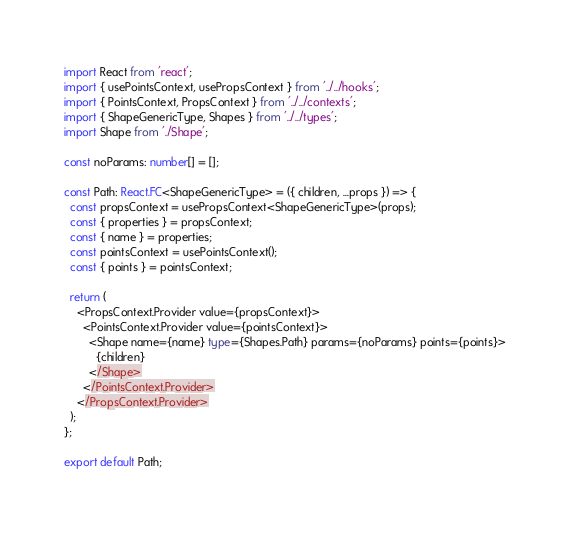<code> <loc_0><loc_0><loc_500><loc_500><_TypeScript_>import React from 'react';
import { usePointsContext, usePropsContext } from '../../hooks';
import { PointsContext, PropsContext } from '../../contexts';
import { ShapeGenericType, Shapes } from '../../types';
import Shape from './Shape';

const noParams: number[] = [];

const Path: React.FC<ShapeGenericType> = ({ children, ...props }) => {
  const propsContext = usePropsContext<ShapeGenericType>(props);
  const { properties } = propsContext;
  const { name } = properties;
  const pointsContext = usePointsContext();
  const { points } = pointsContext;

  return (
    <PropsContext.Provider value={propsContext}>
      <PointsContext.Provider value={pointsContext}>
        <Shape name={name} type={Shapes.Path} params={noParams} points={points}>
          {children}
        </Shape>
      </PointsContext.Provider>
    </PropsContext.Provider>
  );
};

export default Path;
</code> 